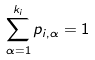<formula> <loc_0><loc_0><loc_500><loc_500>\sum ^ { k _ { i } } _ { \alpha = 1 } p _ { i , \alpha } = 1 \,</formula> 